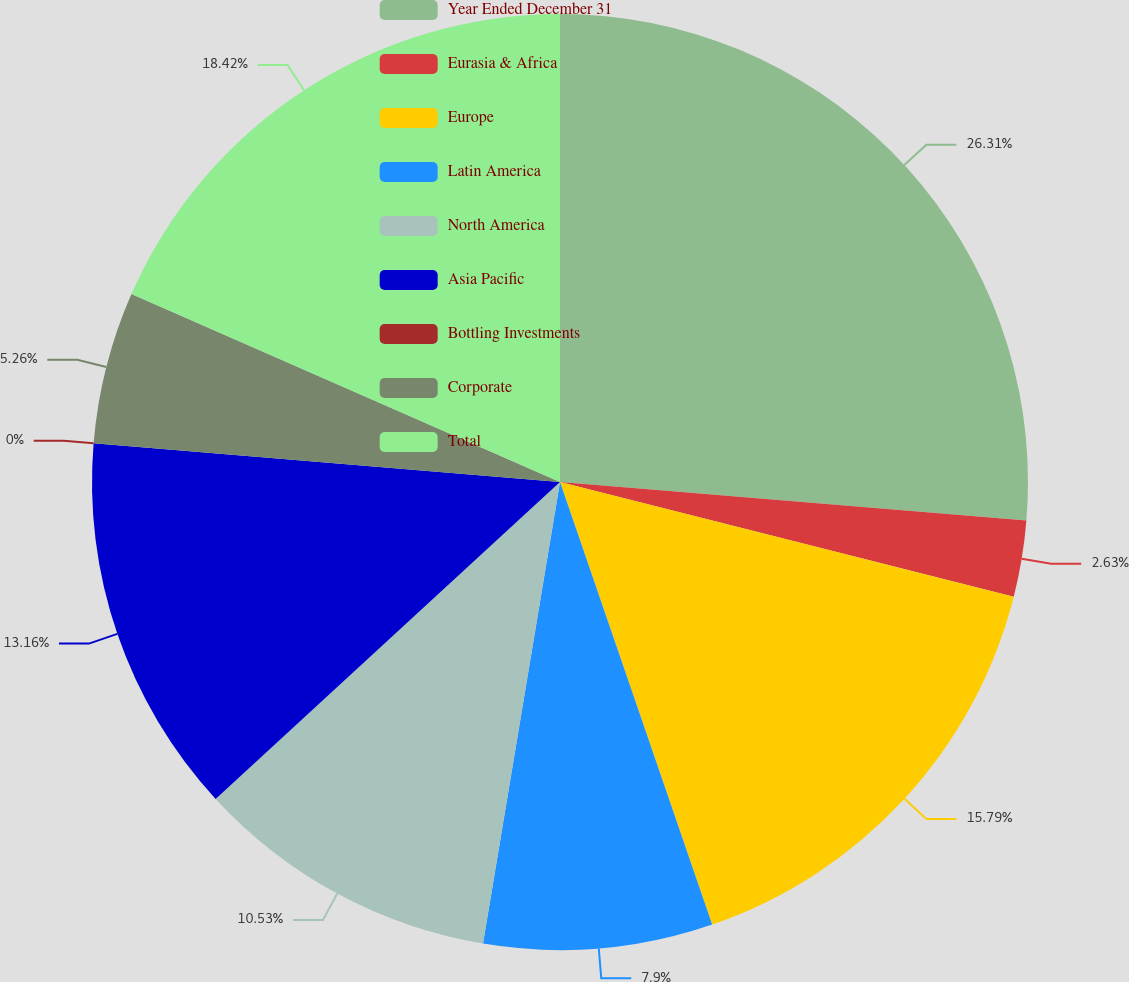Convert chart to OTSL. <chart><loc_0><loc_0><loc_500><loc_500><pie_chart><fcel>Year Ended December 31<fcel>Eurasia & Africa<fcel>Europe<fcel>Latin America<fcel>North America<fcel>Asia Pacific<fcel>Bottling Investments<fcel>Corporate<fcel>Total<nl><fcel>26.31%<fcel>2.63%<fcel>15.79%<fcel>7.9%<fcel>10.53%<fcel>13.16%<fcel>0.0%<fcel>5.26%<fcel>18.42%<nl></chart> 